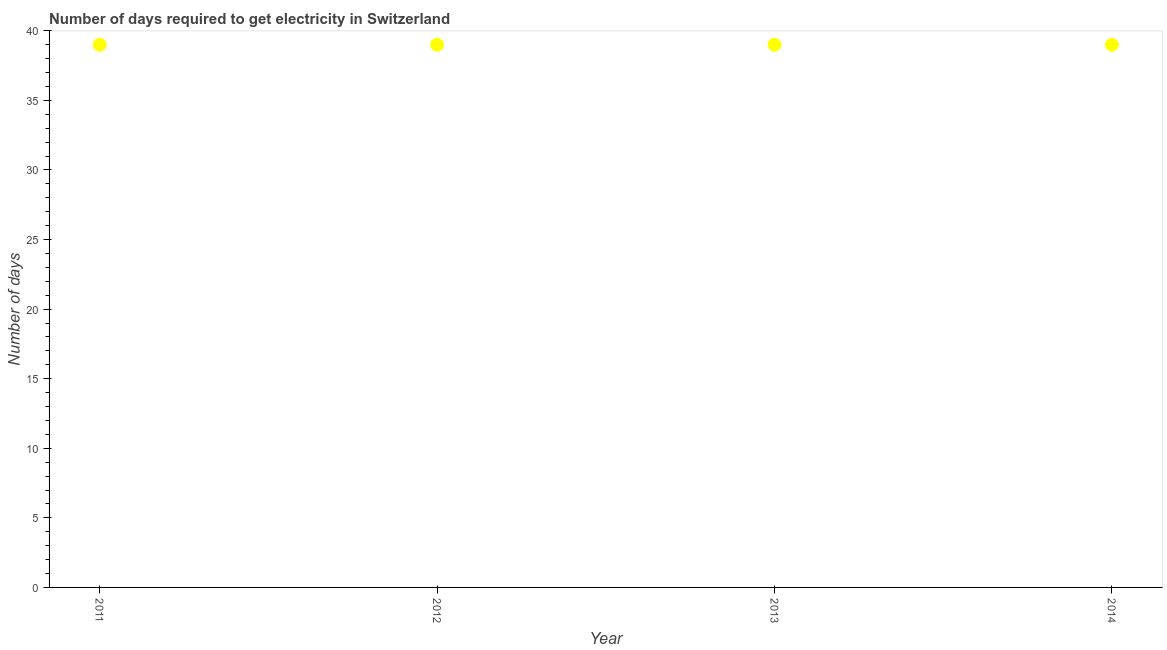What is the time to get electricity in 2011?
Keep it short and to the point. 39. Across all years, what is the maximum time to get electricity?
Make the answer very short. 39. Across all years, what is the minimum time to get electricity?
Keep it short and to the point. 39. In which year was the time to get electricity maximum?
Make the answer very short. 2011. What is the sum of the time to get electricity?
Make the answer very short. 156. What is the difference between the time to get electricity in 2011 and 2014?
Your answer should be compact. 0. What is the average time to get electricity per year?
Your answer should be very brief. 39. In how many years, is the time to get electricity greater than 17 ?
Make the answer very short. 4. What is the ratio of the time to get electricity in 2012 to that in 2013?
Provide a succinct answer. 1. What is the difference between the highest and the lowest time to get electricity?
Keep it short and to the point. 0. Does the time to get electricity monotonically increase over the years?
Offer a terse response. No. How many years are there in the graph?
Your answer should be compact. 4. What is the title of the graph?
Keep it short and to the point. Number of days required to get electricity in Switzerland. What is the label or title of the Y-axis?
Provide a short and direct response. Number of days. What is the Number of days in 2011?
Make the answer very short. 39. What is the Number of days in 2013?
Keep it short and to the point. 39. What is the Number of days in 2014?
Provide a succinct answer. 39. What is the difference between the Number of days in 2011 and 2013?
Ensure brevity in your answer.  0. What is the difference between the Number of days in 2011 and 2014?
Provide a succinct answer. 0. What is the difference between the Number of days in 2012 and 2013?
Your response must be concise. 0. What is the difference between the Number of days in 2013 and 2014?
Your answer should be compact. 0. What is the ratio of the Number of days in 2011 to that in 2012?
Provide a short and direct response. 1. What is the ratio of the Number of days in 2011 to that in 2013?
Ensure brevity in your answer.  1. What is the ratio of the Number of days in 2012 to that in 2013?
Offer a very short reply. 1. What is the ratio of the Number of days in 2012 to that in 2014?
Ensure brevity in your answer.  1. 